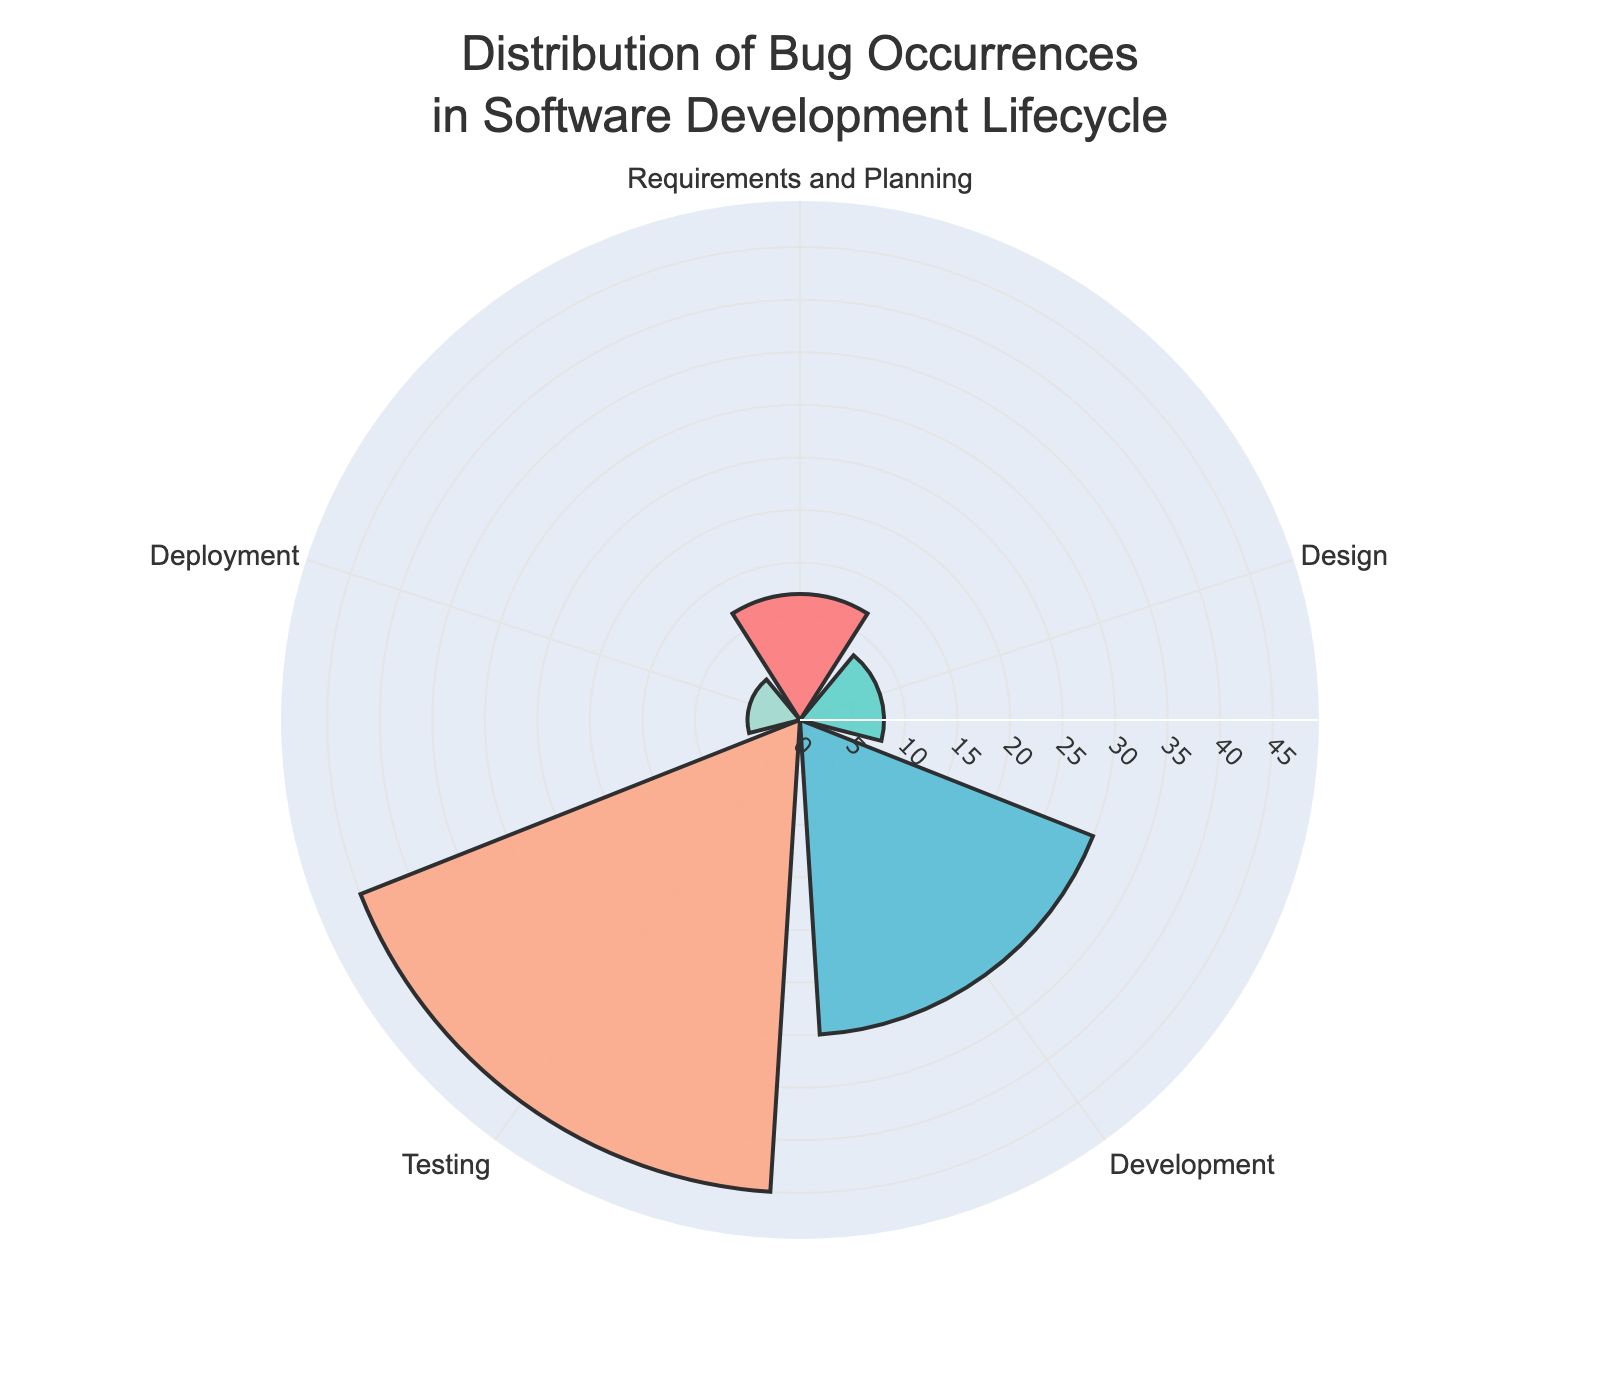What is the title of the chart? The title is usually found at the top of the chart where it describes the content. The title in this chart reads as "Distribution of Bug Occurrences in Software Development Lifecycle".
Answer: Distribution of Bug Occurrences in Software Development Lifecycle Which stage has the highest percentage of bug occurrences? To identify the stage with the highest percentage, look for the tallest bar in the polar area chart. The stage labeled "Testing" has the longest bar extending to 45%.
Answer: Testing How does the percentage of bugs during Development compare to Deployment? Compare the heights of the bars for "Development" and "Deployment". The percentage for "Development" is 30%, while "Deployment" is 5%.
Answer: Development has a higher percentage than Deployment What is the total percentage of bugs for Design and Deployment combined? To find the total percentage, add the percentages for "Design" (8%) and "Deployment" (5%). Calculating 8% + 5% gives 13%.
Answer: 13% Which stages have less than 10% of bug occurrences? Find the bars with heights less than 10%. The stages are "Design" at 8% and "Deployment" at 5%.
Answer: Design and Deployment What is the percentage difference between Testing and Requirements and Planning? Subtract the percentage of "Requirements and Planning" (12%) from "Testing" (45%). The difference is 45% - 12% = 33%.
Answer: 33% In which stages do the combined percentages of bug occurrences exceed 50%? Adding the percentages of Development (30%) and Testing (45%) equals 30% + 45% = 75%, which exceeds 50%.
Answer: Development and Testing What color represents the Design stage? Look at the color of the bar labeled "Design". The color is teal, as it can be identified by its unique hue.
Answer: Teal What is the average percentage of bug occurrences across all stages? To find the average, add all percentages (12% + 8% + 30% + 45% + 5%) and divide by the number of stages (5). The sum is 100%, so the average is 100% / 5 = 20%.
Answer: 20% Which stage accounts for the smallest portion of bug occurrences? Compare the sizes of the bars; the shortest bar corresponds to Deployment, which accounts for 5%.
Answer: Deployment 